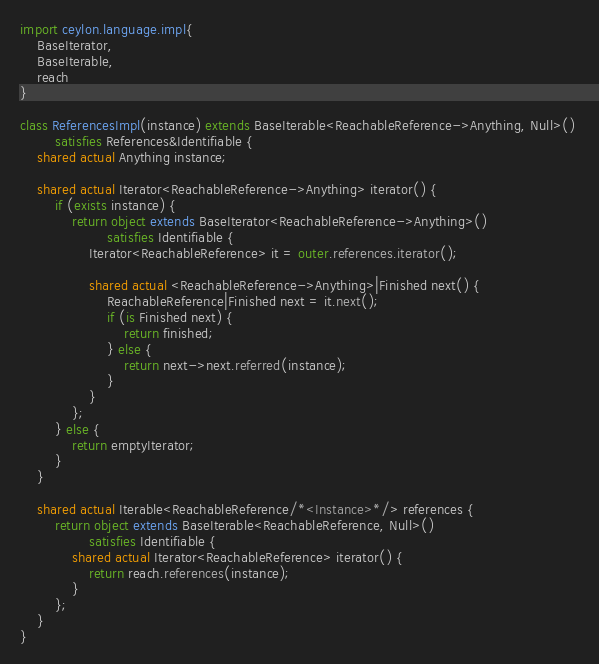<code> <loc_0><loc_0><loc_500><loc_500><_Ceylon_>import ceylon.language.impl{
    BaseIterator, 
    BaseIterable,
    reach
}

class ReferencesImpl(instance) extends BaseIterable<ReachableReference->Anything, Null>() 
        satisfies References&Identifiable {
    shared actual Anything instance;
    
    shared actual Iterator<ReachableReference->Anything> iterator() {
        if (exists instance) {
            return object extends BaseIterator<ReachableReference->Anything>() 
                    satisfies Identifiable {
                Iterator<ReachableReference> it = outer.references.iterator();
                
                shared actual <ReachableReference->Anything>|Finished next() {
                    ReachableReference|Finished next = it.next();
                    if (is Finished next) {
                        return finished;
                    } else {
                        return next->next.referred(instance);
                    }
                }
            };
        } else {
            return emptyIterator;
        }
    }
    
    shared actual Iterable<ReachableReference/*<Instance>*/> references {
        return object extends BaseIterable<ReachableReference, Null>() 
                satisfies Identifiable {
            shared actual Iterator<ReachableReference> iterator() {
                return reach.references(instance);
            }
        };
    }
}
</code> 